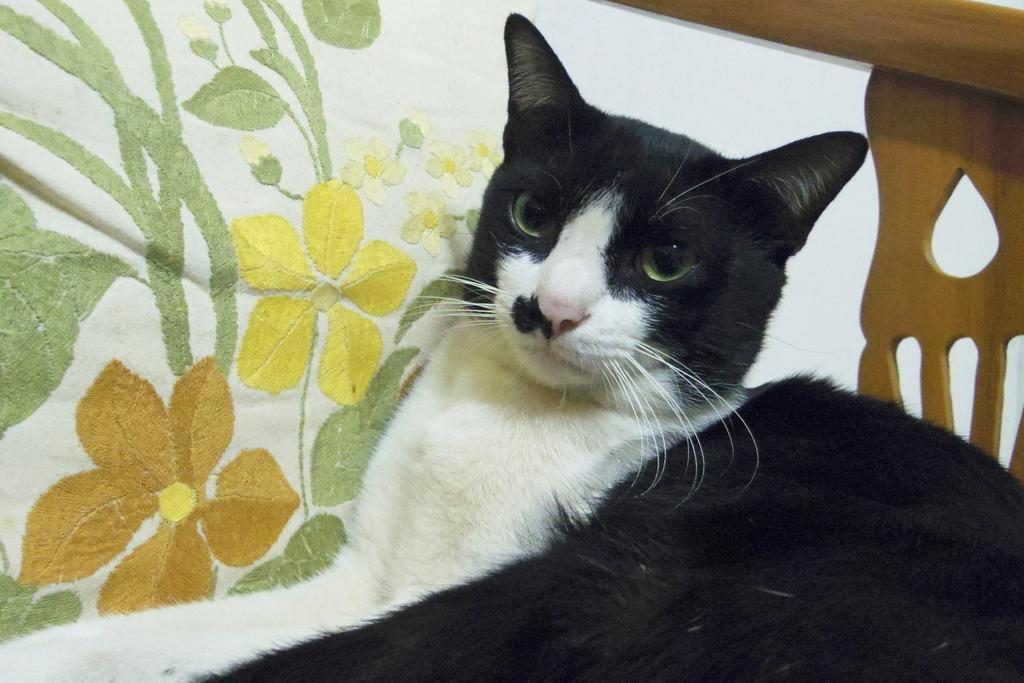What type of animal is in the image? There is a cat in the image. Where is the cat located? The cat is on a blanket. What other object can be seen in the image? There is a wooden object in the image. What type of flower is blooming on the cat's head in the image? There is no flower present on the cat's head in the image. 